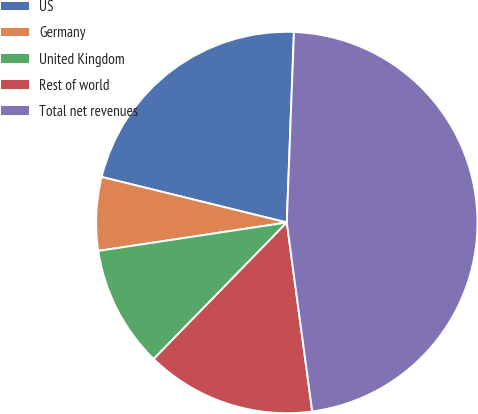Convert chart. <chart><loc_0><loc_0><loc_500><loc_500><pie_chart><fcel>US<fcel>Germany<fcel>United Kingdom<fcel>Rest of world<fcel>Total net revenues<nl><fcel>21.76%<fcel>6.22%<fcel>10.32%<fcel>14.43%<fcel>47.27%<nl></chart> 